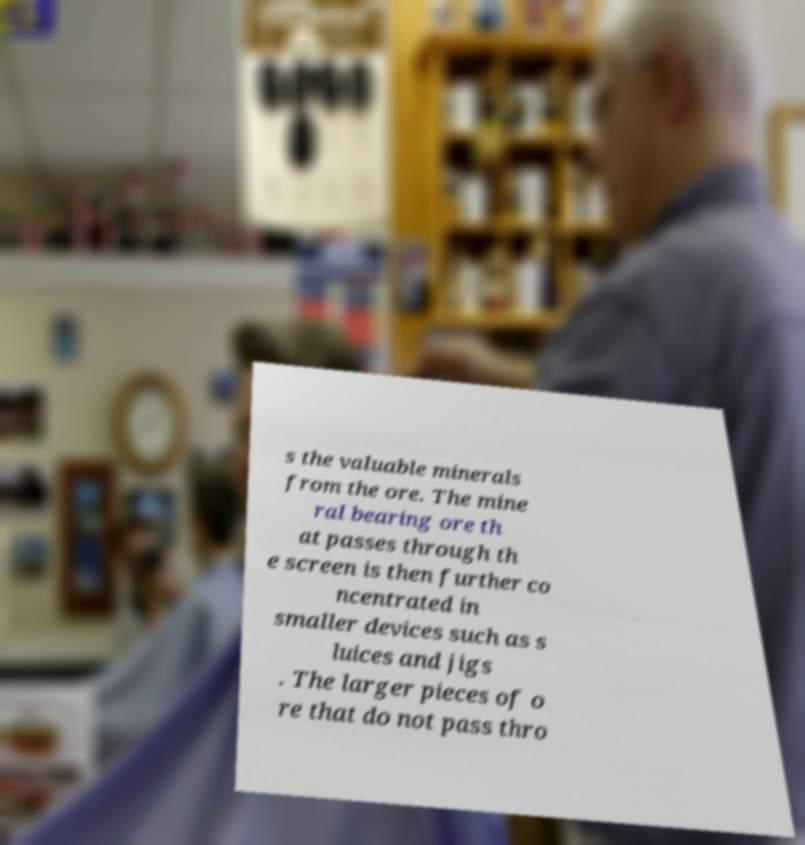What messages or text are displayed in this image? I need them in a readable, typed format. s the valuable minerals from the ore. The mine ral bearing ore th at passes through th e screen is then further co ncentrated in smaller devices such as s luices and jigs . The larger pieces of o re that do not pass thro 